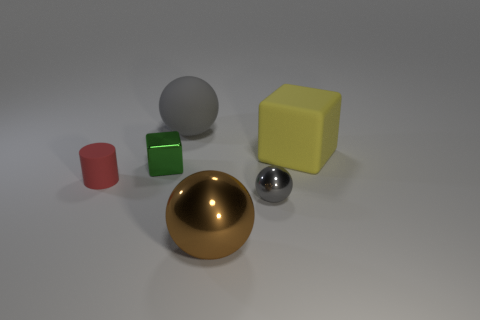Subtract all tiny balls. How many balls are left? 2 Add 3 large green shiny cylinders. How many objects exist? 9 Subtract all brown cylinders. How many gray spheres are left? 2 Subtract all brown balls. How many balls are left? 2 Subtract all blocks. How many objects are left? 4 Subtract 1 spheres. How many spheres are left? 2 Subtract all green spheres. Subtract all cyan cubes. How many spheres are left? 3 Subtract all tiny shiny spheres. Subtract all brown shiny things. How many objects are left? 4 Add 4 red rubber objects. How many red rubber objects are left? 5 Add 2 tiny gray metallic things. How many tiny gray metallic things exist? 3 